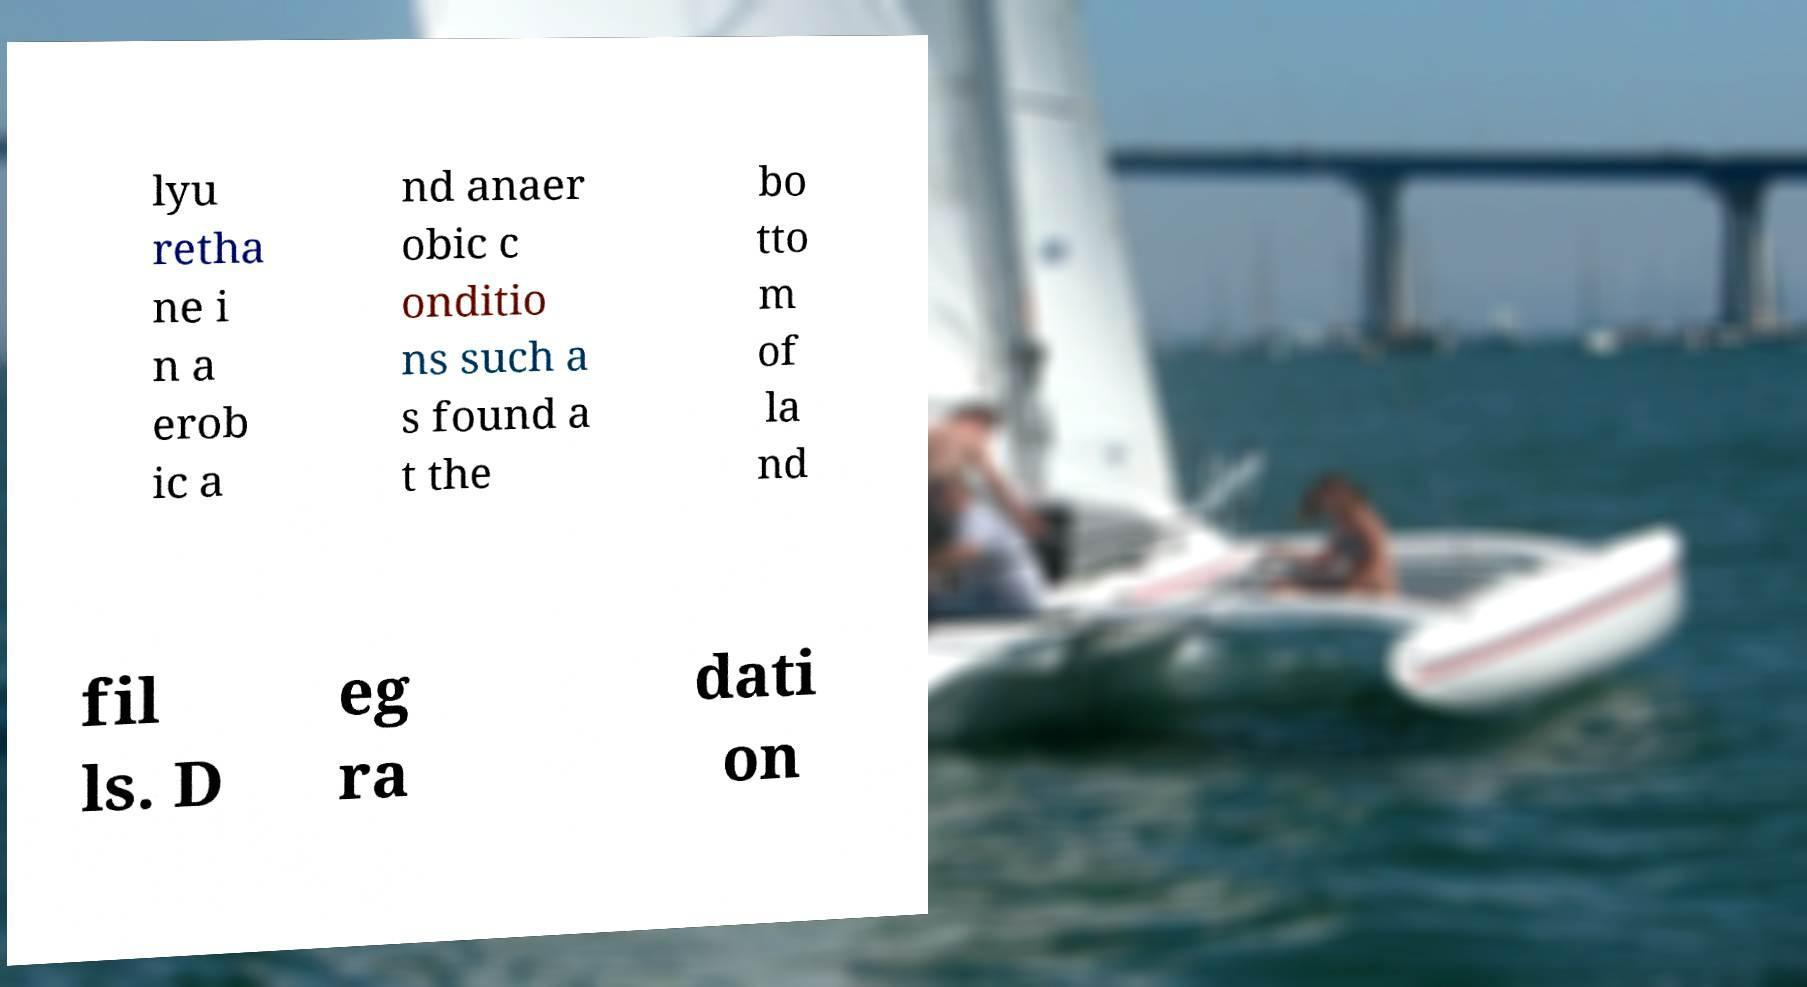Please identify and transcribe the text found in this image. lyu retha ne i n a erob ic a nd anaer obic c onditio ns such a s found a t the bo tto m of la nd fil ls. D eg ra dati on 